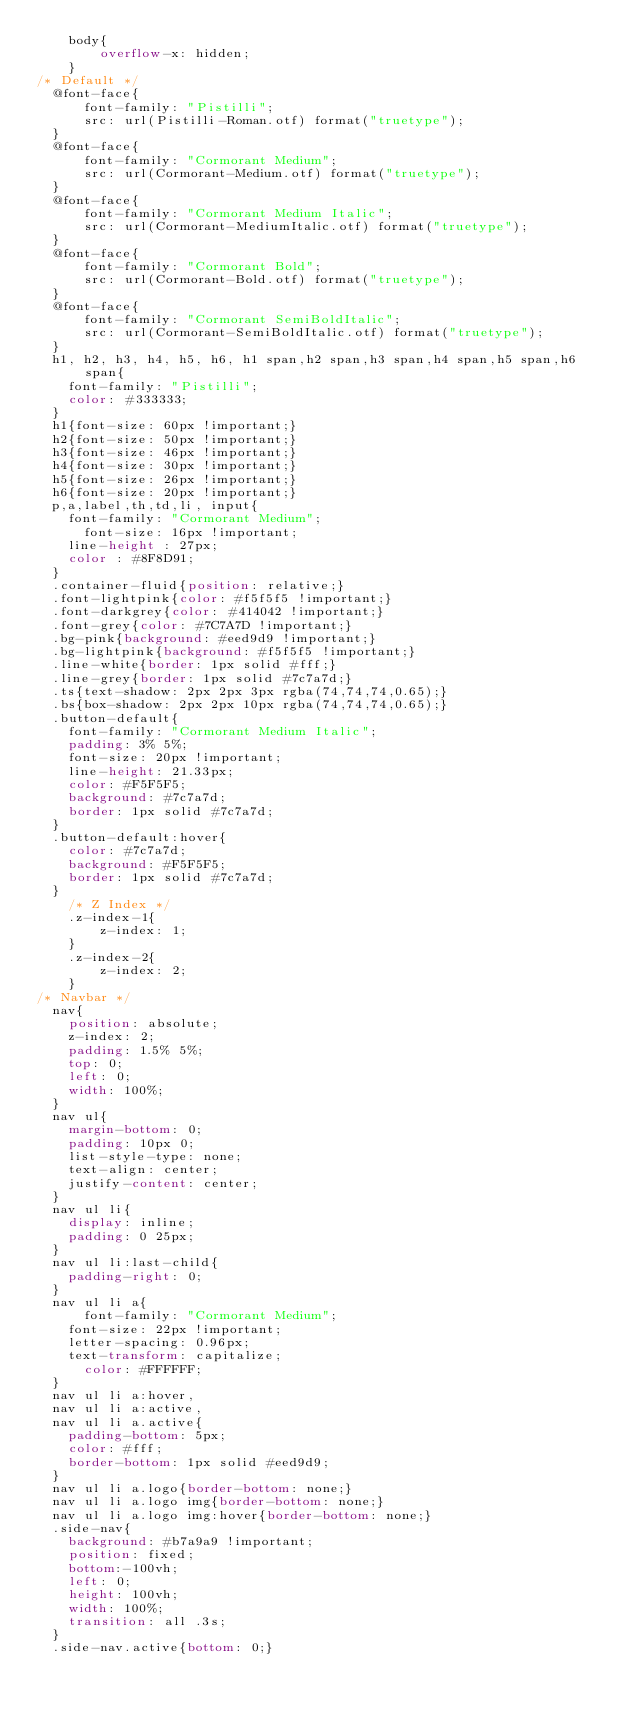<code> <loc_0><loc_0><loc_500><loc_500><_CSS_>    body{
        overflow-x: hidden;
    }
/* Default */
	@font-face{
	    font-family: "Pistilli";
	    src: url(Pistilli-Roman.otf) format("truetype");
	}
	@font-face{
	    font-family: "Cormorant Medium";
	    src: url(Cormorant-Medium.otf) format("truetype");
	}
	@font-face{
	    font-family: "Cormorant Medium Italic";
	    src: url(Cormorant-MediumItalic.otf) format("truetype");
	}
	@font-face{
	    font-family: "Cormorant Bold";
	    src: url(Cormorant-Bold.otf) format("truetype");
	}
	@font-face{
	    font-family: "Cormorant SemiBoldItalic";
	    src: url(Cormorant-SemiBoldItalic.otf) format("truetype");
	}
	h1, h2, h3, h4, h5, h6, h1 span,h2 span,h3 span,h4 span,h5 span,h6 span{
		font-family: "Pistilli";
		color: #333333;
	}
	h1{font-size: 60px !important;}
	h2{font-size: 50px !important;}
	h3{font-size: 46px !important;}
	h4{font-size: 30px !important;}
	h5{font-size: 26px !important;}
	h6{font-size: 20px !important;}
	p,a,label,th,td,li, input{
		font-family: "Cormorant Medium";
	  	font-size: 16px !important;
		line-height : 27px;
		color : #8F8D91;
	}
	.container-fluid{position: relative;}
	.font-lightpink{color: #f5f5f5 !important;}
	.font-darkgrey{color: #414042 !important;}
	.font-grey{color: #7C7A7D !important;}
	.bg-pink{background: #eed9d9 !important;}
	.bg-lightpink{background: #f5f5f5 !important;}
	.line-white{border: 1px solid #fff;}
	.line-grey{border: 1px solid #7c7a7d;}
	.ts{text-shadow: 2px 2px 3px rgba(74,74,74,0.65);}
	.bs{box-shadow: 2px 2px 10px rgba(74,74,74,0.65);}
	.button-default{
		font-family: "Cormorant Medium Italic";
		padding: 3% 5%;
		font-size: 20px !important;
		line-height: 21.33px;
		color: #F5F5F5;
		background: #7c7a7d;
		border: 1px solid #7c7a7d;
	}
	.button-default:hover{
		color: #7c7a7d;
		background: #F5F5F5;
		border: 1px solid #7c7a7d;
	}
    /* Z Index */
    .z-index-1{
        z-index: 1;
    }
    .z-index-2{
        z-index: 2;
    }
/* Navbar */
	nav{
		position: absolute;
		z-index: 2;
		padding: 1.5% 5%;
		top: 0;
		left: 0;
		width: 100%;
	}
	nav ul{
		margin-bottom: 0;
		padding: 10px 0;
		list-style-type: none;
		text-align: center;
		justify-content: center;
	}
	nav ul li{
		display: inline;
		padding: 0 25px;
	}
	nav ul li:last-child{
		padding-right: 0;
	}
	nav ul li a{
	    font-family: "Cormorant Medium";
		font-size: 22px !important;
		letter-spacing: 0.96px;
		text-transform: capitalize;
  		color: #FFFFFF;
	}
	nav ul li a:hover,
	nav ul li a:active,
	nav ul li a.active{
		padding-bottom: 5px;
		color: #fff;
		border-bottom: 1px solid #eed9d9;
	}
	nav ul li a.logo{border-bottom: none;}
	nav ul li a.logo img{border-bottom: none;}
	nav ul li a.logo img:hover{border-bottom: none;}
	.side-nav{
		background: #b7a9a9 !important;
		position: fixed;
		bottom:-100vh;
		left: 0;
		height: 100vh;
		width: 100%;
		transition: all .3s;
	}
	.side-nav.active{bottom: 0;}</code> 